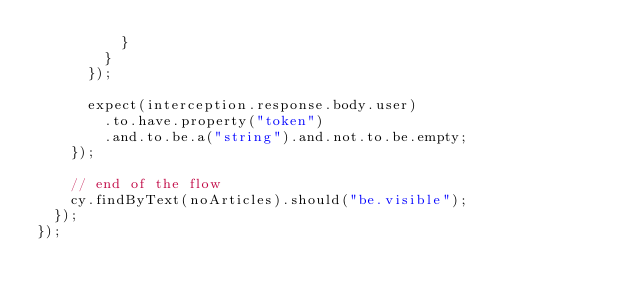Convert code to text. <code><loc_0><loc_0><loc_500><loc_500><_JavaScript_>          }
        }
      });

      expect(interception.response.body.user)
        .to.have.property("token")
        .and.to.be.a("string").and.not.to.be.empty;
    });

    // end of the flow
    cy.findByText(noArticles).should("be.visible");
  });
});
</code> 